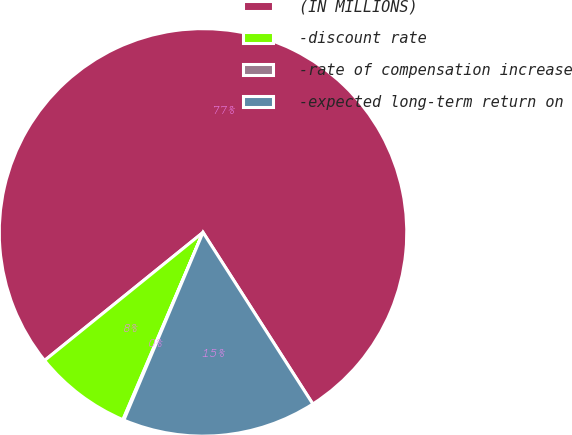Convert chart. <chart><loc_0><loc_0><loc_500><loc_500><pie_chart><fcel>(IN MILLIONS)<fcel>-discount rate<fcel>-rate of compensation increase<fcel>-expected long-term return on<nl><fcel>76.76%<fcel>7.75%<fcel>0.08%<fcel>15.41%<nl></chart> 